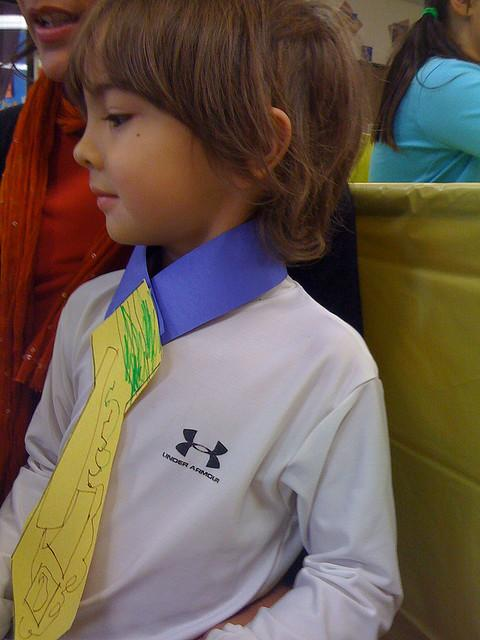What is the small child's tie made out of? paper 